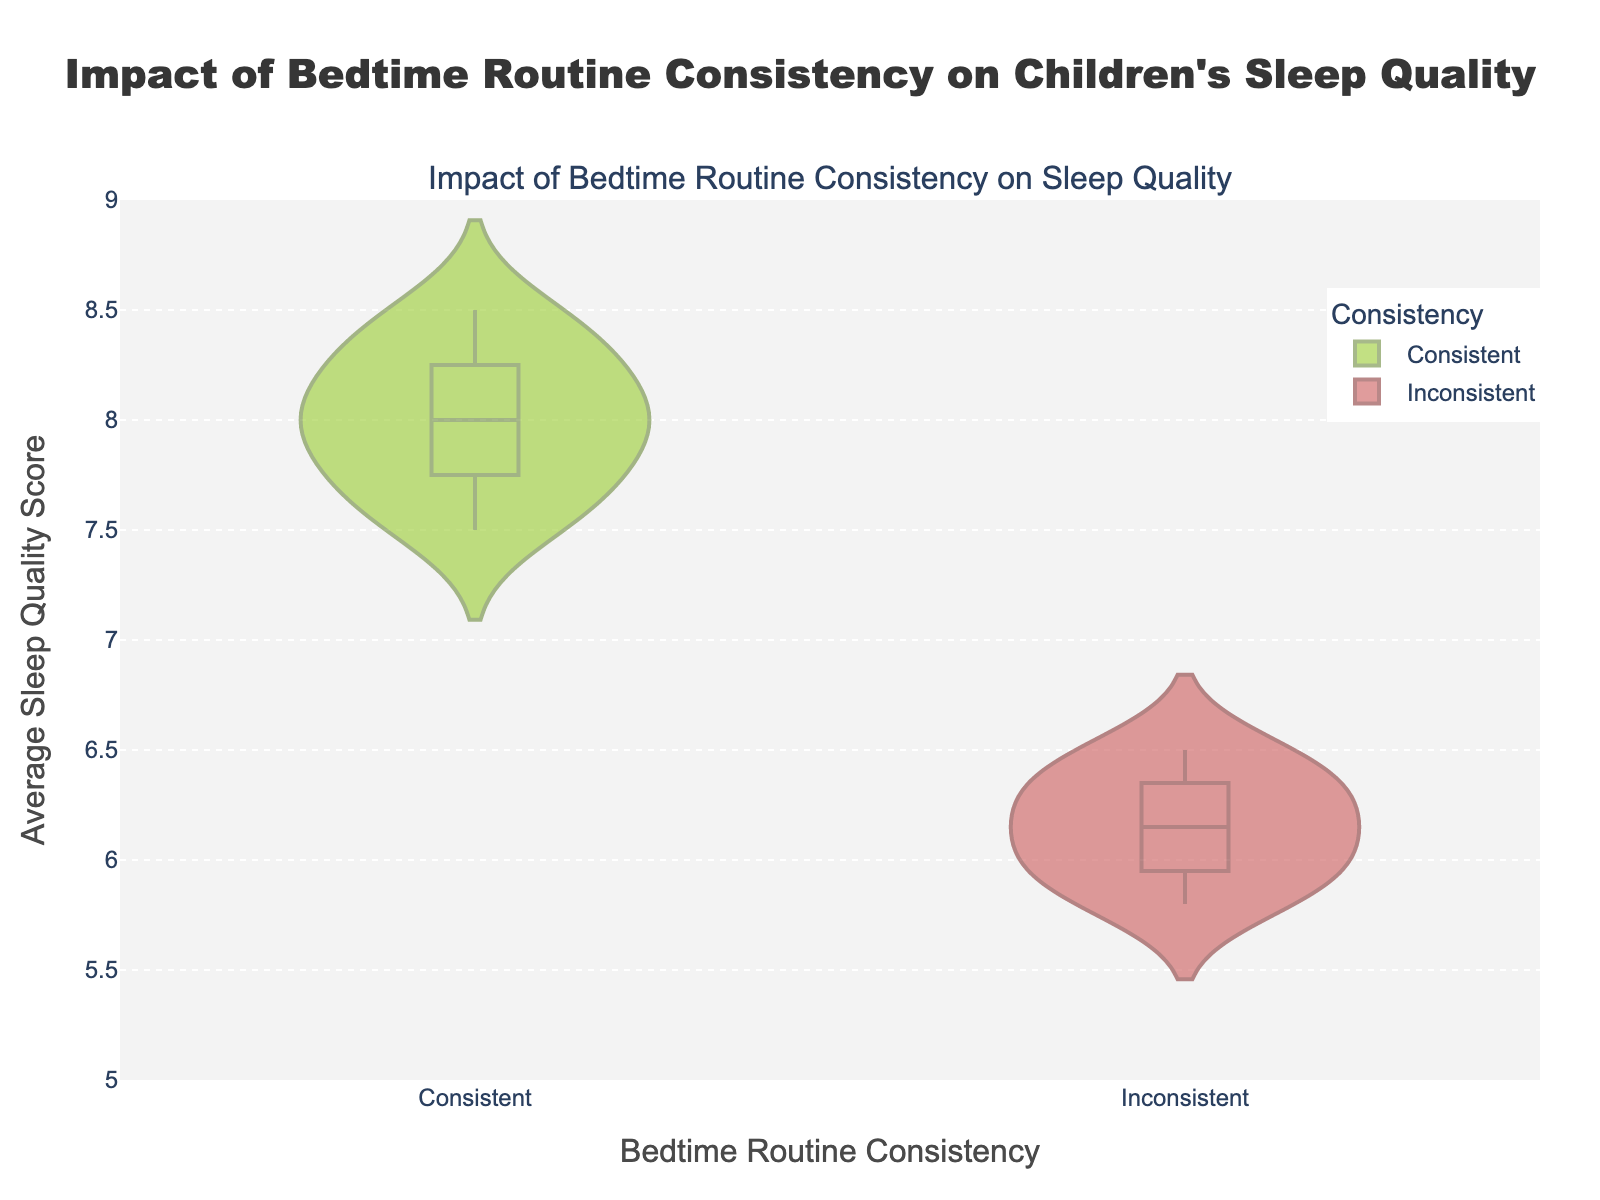What are the two categories of bedtime routine consistency displayed in the plot? The plot shows two categories: "Consistent" and "Inconsistent".
Answer: Consistent, Inconsistent What is the range of the y-axis in the plot? The y-axis in the plot ranges from 5 to 9.
Answer: 5 to 9 Which group appears to have a higher average sleep quality score? From the density plots, the "Consistent" group appears to have a higher average sleep quality score since its scores are generally higher.
Answer: Consistent What is the title of the plot? The title of the plot is "Impact of Bedtime Routine Consistency on Children's Sleep Quality".
Answer: Impact of Bedtime Routine Consistency on Children's Sleep Quality How are the data points in each category represented visually in the figure? The data points in each category are represented using violin plots, which show the density, distribution, and a central box for each category.
Answer: Violin plots Comparing the "Consistent" and "Inconsistent" groups, which has a wider spread of sleep quality scores? The "Inconsistent" group has a wider spread as the data points are more spread out between 5.8 and 6.5, while the "Consistent" group is more tightly clustered with higher scores.
Answer: Inconsistent What is the median sleep quality score for the "Consistent" group? The median is represented by the center line within the box of the violin plot for the "Consistent" group, which appears around 8.0.
Answer: 8.0 Is there any overlap in the sleep quality scores between the "Consistent" and "Inconsistent" groups? Yes, there is some overlap in the sleep quality scores, but "Consistent" group scores are generally higher and less spread out compared to the "Inconsistent" group.
Answer: Yes Which group exhibits more variability in sleep quality scores based on the figure? The "Inconsistent" group exhibits more variability in sleep quality scores, as indicated by the broader spread and distribution of the plot.
Answer: Inconsistent 